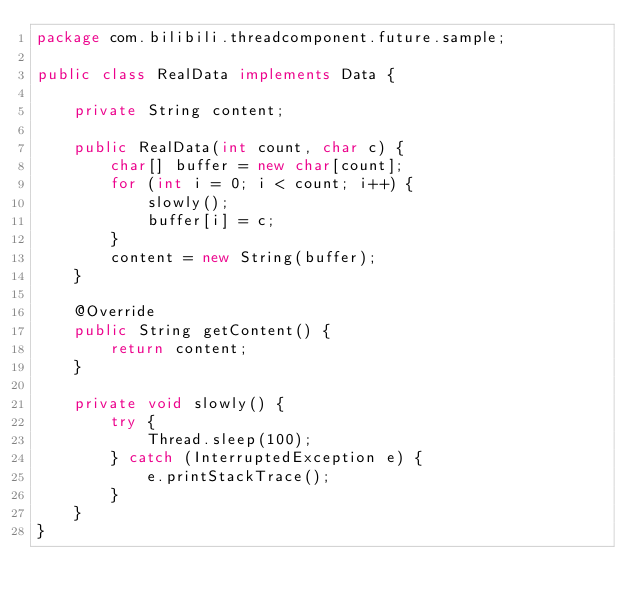Convert code to text. <code><loc_0><loc_0><loc_500><loc_500><_Java_>package com.bilibili.threadcomponent.future.sample;

public class RealData implements Data {

    private String content;

    public RealData(int count, char c) {
        char[] buffer = new char[count];
        for (int i = 0; i < count; i++) {
            slowly();
            buffer[i] = c;
        }
        content = new String(buffer);
    }

    @Override
    public String getContent() {
        return content;
    }

    private void slowly() {
        try {
            Thread.sleep(100);
        } catch (InterruptedException e) {
            e.printStackTrace();
        }
    }
}
</code> 